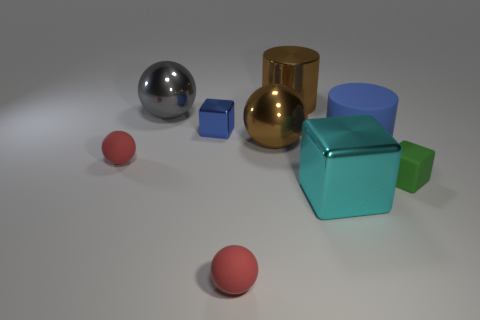Is the red object that is on the left side of the small blue shiny block made of the same material as the cylinder that is on the left side of the large cyan thing?
Offer a very short reply. No. The big matte thing that is the same color as the tiny metal object is what shape?
Ensure brevity in your answer.  Cylinder. How many things are either tiny red spheres in front of the large cyan shiny block or small red rubber spheres left of the large gray metallic ball?
Make the answer very short. 2. There is a sphere in front of the large cyan metallic cube; is its color the same as the matte sphere that is left of the tiny blue shiny object?
Offer a very short reply. Yes. The object that is both on the left side of the green object and on the right side of the big cyan shiny thing has what shape?
Provide a short and direct response. Cylinder. What color is the matte block that is the same size as the blue shiny cube?
Give a very brief answer. Green. Are there any matte cylinders that have the same color as the tiny metal cube?
Give a very brief answer. Yes. There is a red sphere on the left side of the gray ball; is it the same size as the red sphere that is right of the gray shiny thing?
Offer a very short reply. Yes. What material is the sphere that is right of the blue metal cube and behind the rubber cube?
Your answer should be compact. Metal. There is a matte object that is the same color as the tiny shiny block; what is its size?
Keep it short and to the point. Large. 